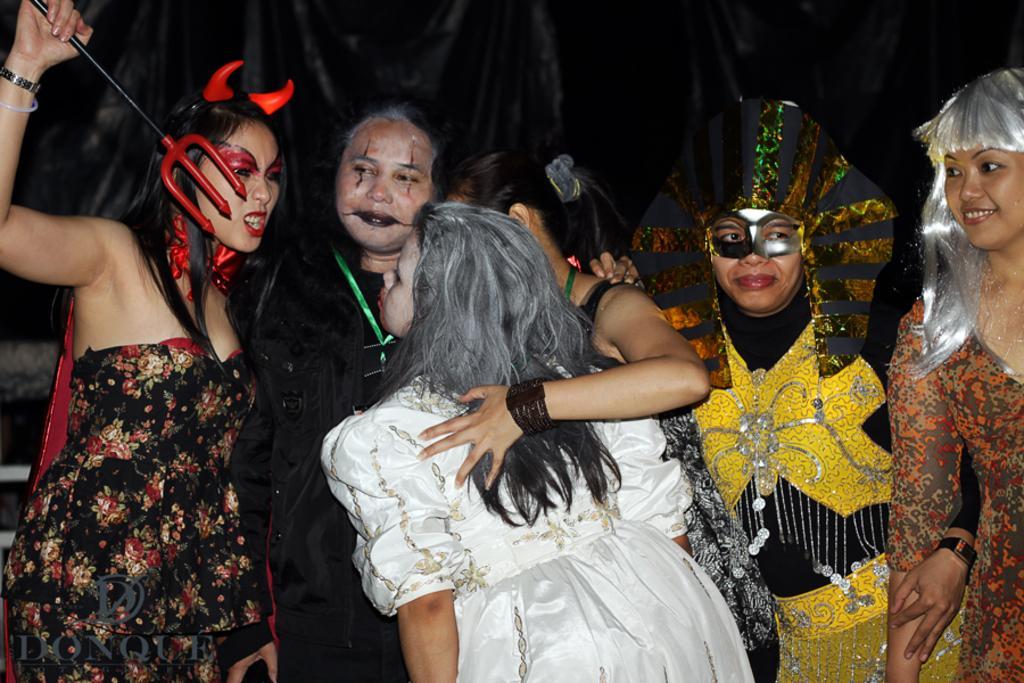Please provide a concise description of this image. In this image there are few people in Halloween costumes in which one of them holds an object and there is a black color object in the background. 